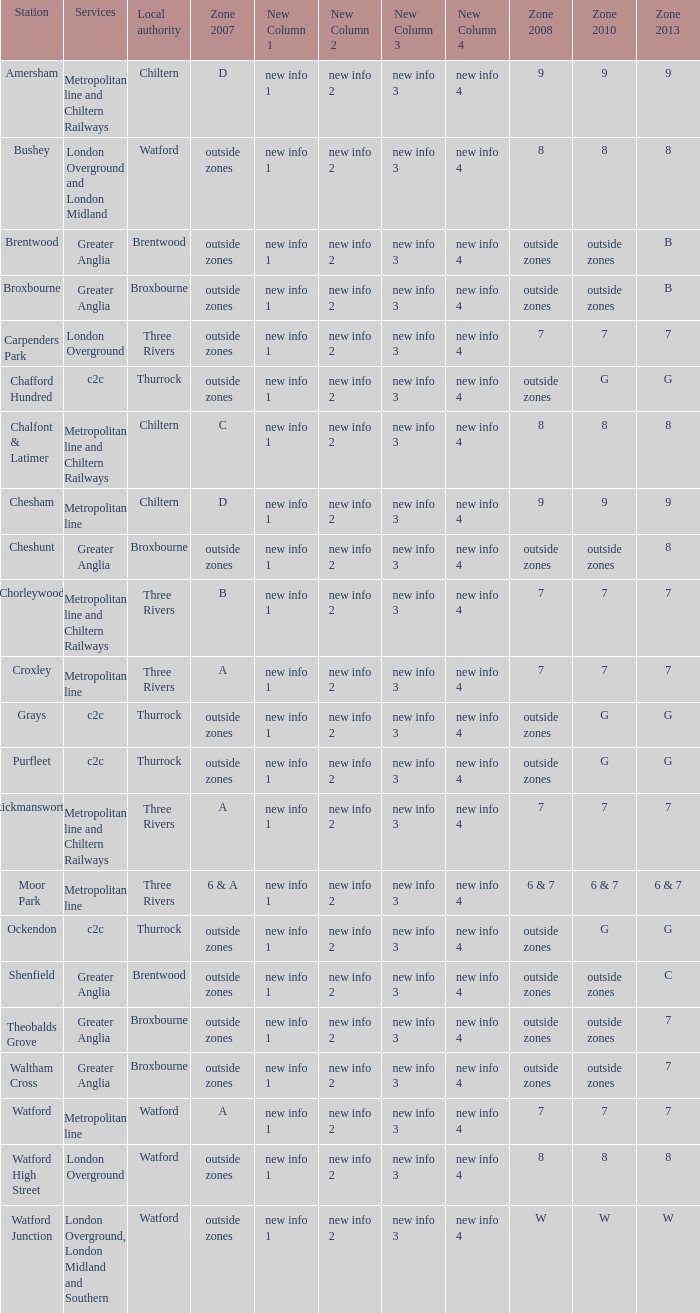Which Station has a Zone 2010 of 7? Carpenders Park, Chorleywood, Croxley, Rickmansworth, Watford. Can you parse all the data within this table? {'header': ['Station', 'Services', 'Local authority', 'Zone 2007', 'New Column 1', 'New Column 2', 'New Column 3', 'New Column 4', 'Zone 2008', 'Zone 2010', 'Zone 2013'], 'rows': [['Amersham', 'Metropolitan line and Chiltern Railways', 'Chiltern', 'D', 'new info 1', 'new info 2', 'new info 3', 'new info 4', '9', '9', '9'], ['Bushey', 'London Overground and London Midland', 'Watford', 'outside zones', 'new info 1', 'new info 2', 'new info 3', 'new info 4', '8', '8', '8'], ['Brentwood', 'Greater Anglia', 'Brentwood', 'outside zones', 'new info 1', 'new info 2', 'new info 3', 'new info 4', 'outside zones', 'outside zones', 'B'], ['Broxbourne', 'Greater Anglia', 'Broxbourne', 'outside zones', 'new info 1', 'new info 2', 'new info 3', 'new info 4', 'outside zones', 'outside zones', 'B'], ['Carpenders Park', 'London Overground', 'Three Rivers', 'outside zones', 'new info 1', 'new info 2', 'new info 3', 'new info 4', '7', '7', '7'], ['Chafford Hundred', 'c2c', 'Thurrock', 'outside zones', 'new info 1', 'new info 2', 'new info 3', 'new info 4', 'outside zones', 'G', 'G'], ['Chalfont & Latimer', 'Metropolitan line and Chiltern Railways', 'Chiltern', 'C', 'new info 1', 'new info 2', 'new info 3', 'new info 4', '8', '8', '8'], ['Chesham', 'Metropolitan line', 'Chiltern', 'D', 'new info 1', 'new info 2', 'new info 3', 'new info 4', '9', '9', '9'], ['Cheshunt', 'Greater Anglia', 'Broxbourne', 'outside zones', 'new info 1', 'new info 2', 'new info 3', 'new info 4', 'outside zones', 'outside zones', '8'], ['Chorleywood', 'Metropolitan line and Chiltern Railways', 'Three Rivers', 'B', 'new info 1', 'new info 2', 'new info 3', 'new info 4', '7', '7', '7'], ['Croxley', 'Metropolitan line', 'Three Rivers', 'A', 'new info 1', 'new info 2', 'new info 3', 'new info 4', '7', '7', '7'], ['Grays', 'c2c', 'Thurrock', 'outside zones', 'new info 1', 'new info 2', 'new info 3', 'new info 4', 'outside zones', 'G', 'G'], ['Purfleet', 'c2c', 'Thurrock', 'outside zones', 'new info 1', 'new info 2', 'new info 3', 'new info 4', 'outside zones', 'G', 'G'], ['Rickmansworth', 'Metropolitan line and Chiltern Railways', 'Three Rivers', 'A', 'new info 1', 'new info 2', 'new info 3', 'new info 4', '7', '7', '7'], ['Moor Park', 'Metropolitan line', 'Three Rivers', '6 & A', 'new info 1', 'new info 2', 'new info 3', 'new info 4', '6 & 7', '6 & 7', '6 & 7'], ['Ockendon', 'c2c', 'Thurrock', 'outside zones', 'new info 1', 'new info 2', 'new info 3', 'new info 4', 'outside zones', 'G', 'G'], ['Shenfield', 'Greater Anglia', 'Brentwood', 'outside zones', 'new info 1', 'new info 2', 'new info 3', 'new info 4', 'outside zones', 'outside zones', 'C'], ['Theobalds Grove', 'Greater Anglia', 'Broxbourne', 'outside zones', 'new info 1', 'new info 2', 'new info 3', 'new info 4', 'outside zones', 'outside zones', '7'], ['Waltham Cross', 'Greater Anglia', 'Broxbourne', 'outside zones', 'new info 1', 'new info 2', 'new info 3', 'new info 4', 'outside zones', 'outside zones', '7'], ['Watford', 'Metropolitan line', 'Watford', 'A', 'new info 1', 'new info 2', 'new info 3', 'new info 4', '7', '7', '7'], ['Watford High Street', 'London Overground', 'Watford', 'outside zones', 'new info 1', 'new info 2', 'new info 3', 'new info 4', '8', '8', '8'], ['Watford Junction', 'London Overground, London Midland and Southern', 'Watford', 'outside zones', 'new info 1', 'new info 2', 'new info 3', 'new info 4', 'W', 'W', 'W']]} 